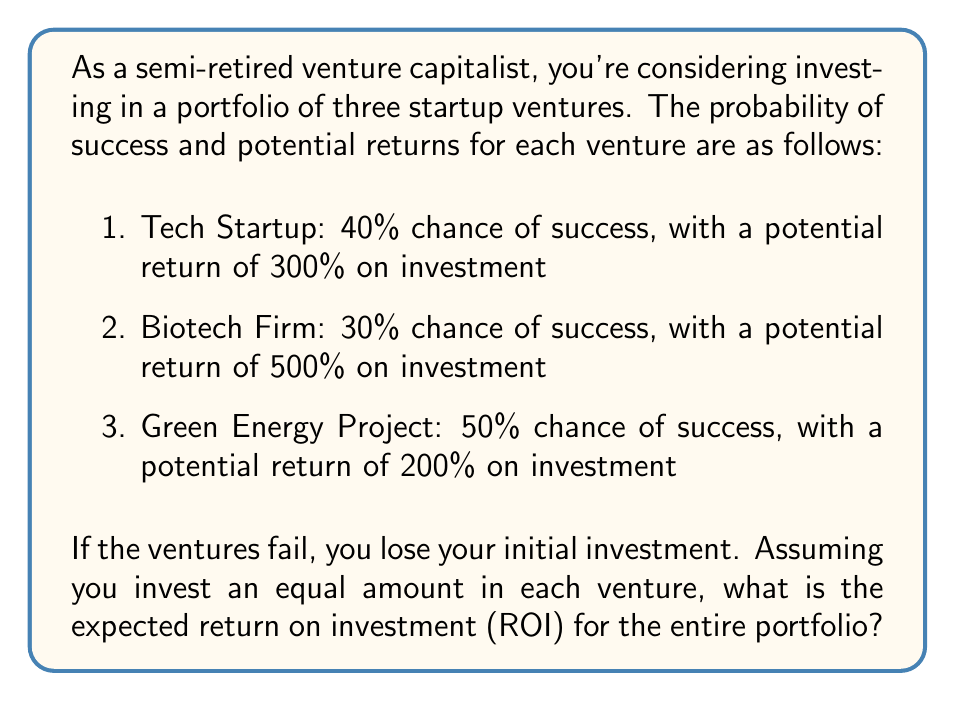Solve this math problem. Let's approach this step-by-step:

1) First, we need to calculate the expected return for each venture individually.

2) For the Tech Startup:
   Expected Return = (Probability of Success × Return if Successful) + (Probability of Failure × Return if Failed)
   $$ E_1 = (0.40 \times 300\%) + (0.60 \times -100\%) = 120\% - 60\% = 60\% $$

3) For the Biotech Firm:
   $$ E_2 = (0.30 \times 500\%) + (0.70 \times -100\%) = 150\% - 70\% = 80\% $$

4) For the Green Energy Project:
   $$ E_3 = (0.50 \times 200\%) + (0.50 \times -100\%) = 100\% - 50\% = 50\% $$

5) Now, since we're investing an equal amount in each venture, the expected return of the portfolio is the average of these three expected returns:

   $$ E_{portfolio} = \frac{E_1 + E_2 + E_3}{3} = \frac{60\% + 80\% + 50\%}{3} = \frac{190\%}{3} \approx 63.33\% $$

Therefore, the expected return on investment for the entire portfolio is approximately 63.33%.
Answer: 63.33% 